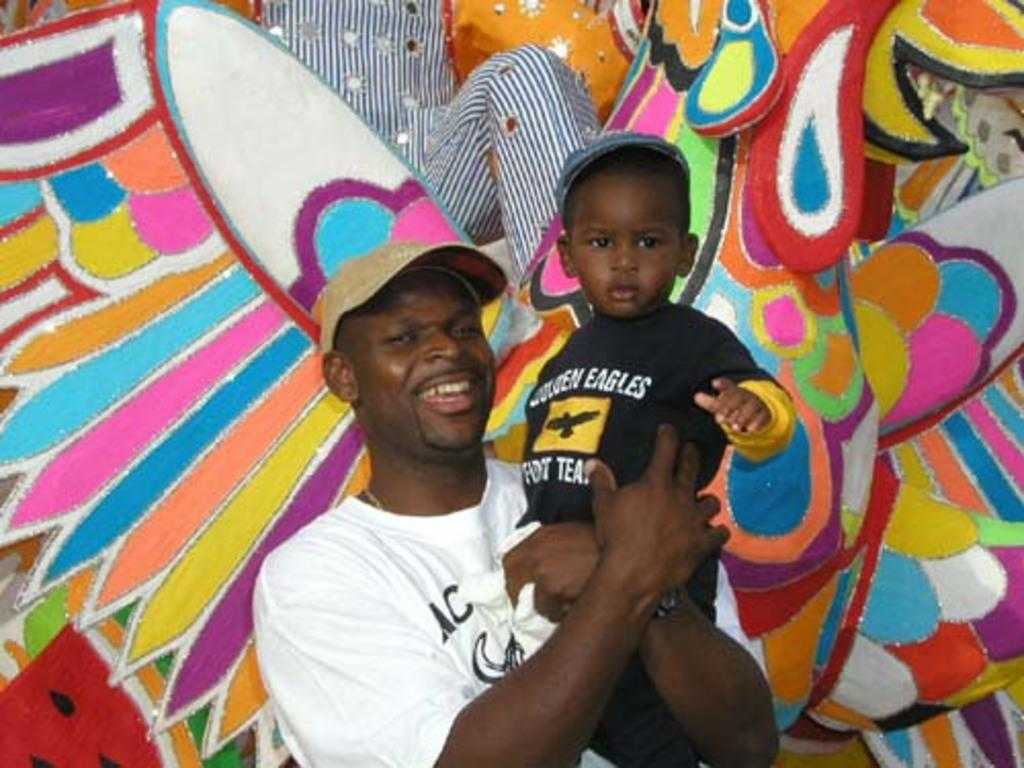<image>
Offer a succinct explanation of the picture presented. A father holds up his son who is wearing a black Eagles shirt. 